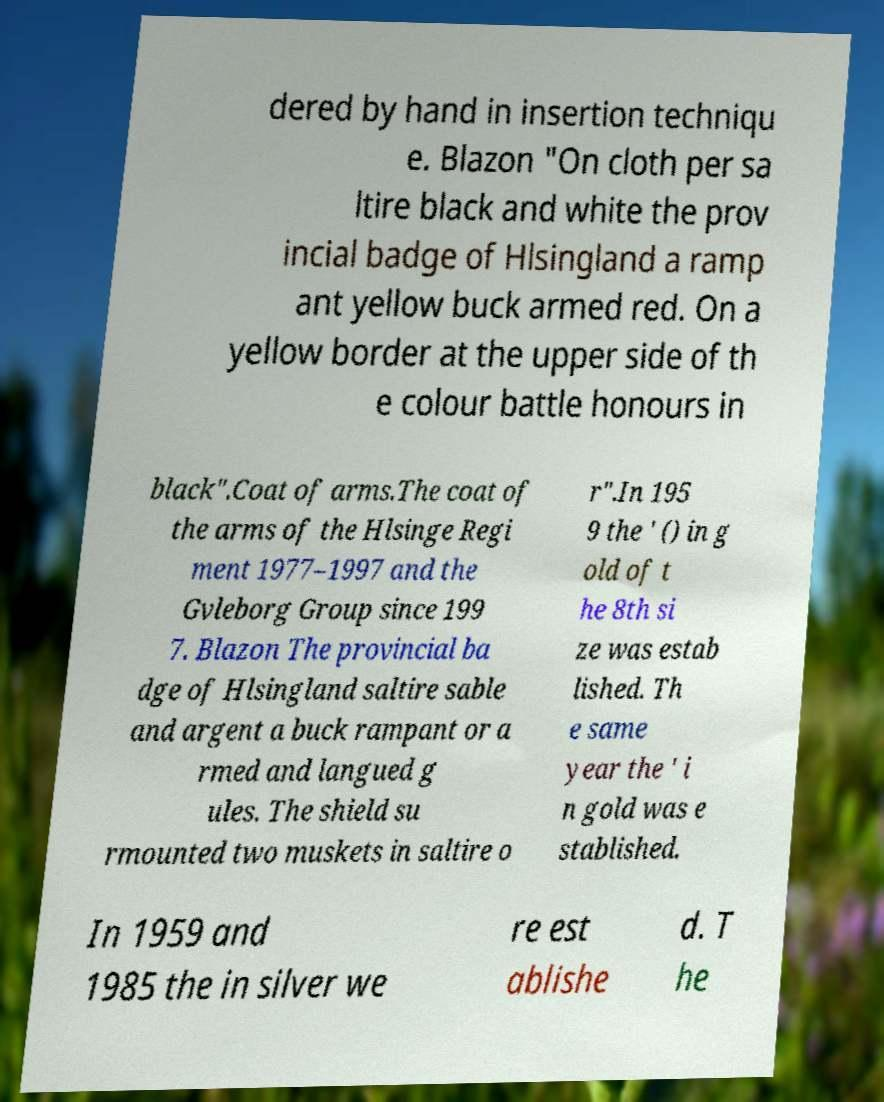There's text embedded in this image that I need extracted. Can you transcribe it verbatim? dered by hand in insertion techniqu e. Blazon "On cloth per sa ltire black and white the prov incial badge of Hlsingland a ramp ant yellow buck armed red. On a yellow border at the upper side of th e colour battle honours in black".Coat of arms.The coat of the arms of the Hlsinge Regi ment 1977–1997 and the Gvleborg Group since 199 7. Blazon The provincial ba dge of Hlsingland saltire sable and argent a buck rampant or a rmed and langued g ules. The shield su rmounted two muskets in saltire o r".In 195 9 the ' () in g old of t he 8th si ze was estab lished. Th e same year the ' i n gold was e stablished. In 1959 and 1985 the in silver we re est ablishe d. T he 